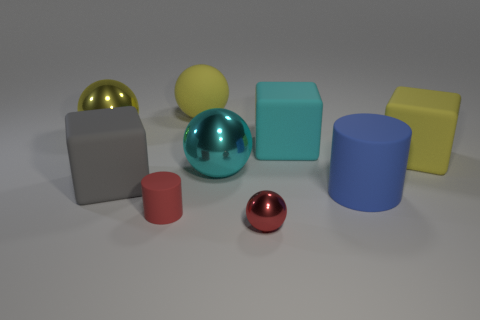How many rubber things are behind the small cylinder and right of the large gray cube? Behind the small cylinder and to the right of the large grey cube, there appear to be three spherical rubber objects. 